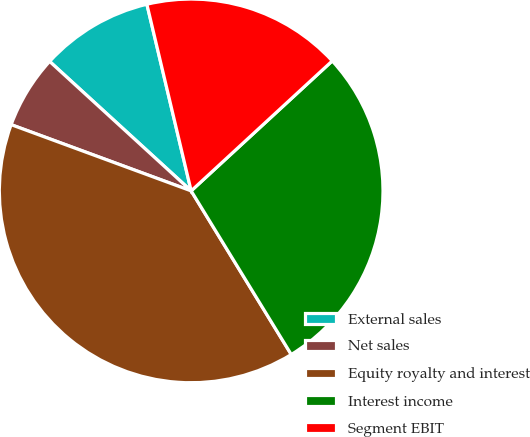Convert chart to OTSL. <chart><loc_0><loc_0><loc_500><loc_500><pie_chart><fcel>External sales<fcel>Net sales<fcel>Equity royalty and interest<fcel>Interest income<fcel>Segment EBIT<nl><fcel>9.5%<fcel>6.18%<fcel>39.35%<fcel>28.11%<fcel>16.86%<nl></chart> 